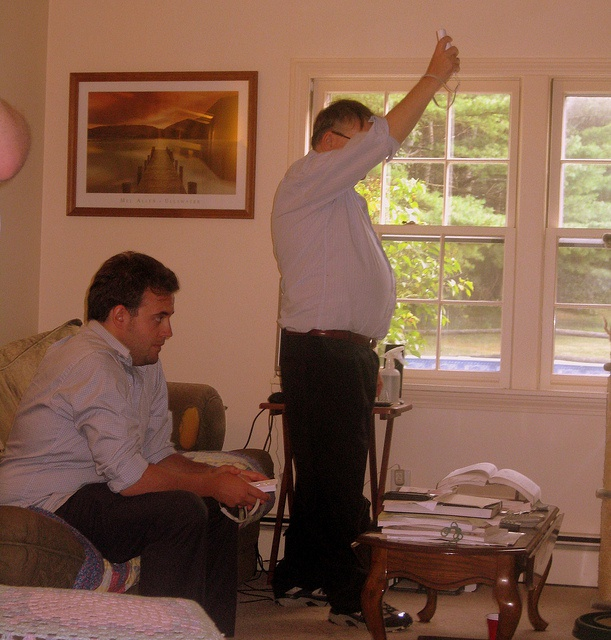Describe the objects in this image and their specific colors. I can see people in brown, black, and maroon tones, people in brown, black, gray, and maroon tones, couch in brown, maroon, and black tones, book in brown, gray, and lightpink tones, and book in brown and gray tones in this image. 